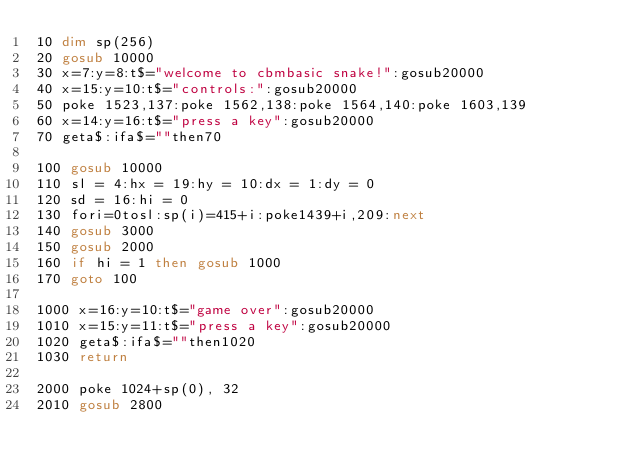Convert code to text. <code><loc_0><loc_0><loc_500><loc_500><_VisualBasic_>10 dim sp(256)
20 gosub 10000
30 x=7:y=8:t$="welcome to cbmbasic snake!":gosub20000
40 x=15:y=10:t$="controls:":gosub20000
50 poke 1523,137:poke 1562,138:poke 1564,140:poke 1603,139
60 x=14:y=16:t$="press a key":gosub20000
70 geta$:ifa$=""then70

100 gosub 10000
110 sl = 4:hx = 19:hy = 10:dx = 1:dy = 0
120 sd = 16:hi = 0
130 fori=0tosl:sp(i)=415+i:poke1439+i,209:next
140 gosub 3000
150 gosub 2000
160 if hi = 1 then gosub 1000 
170 goto 100

1000 x=16:y=10:t$="game over":gosub20000
1010 x=15:y=11:t$="press a key":gosub20000
1020 geta$:ifa$=""then1020
1030 return

2000 poke 1024+sp(0), 32
2010 gosub 2800</code> 